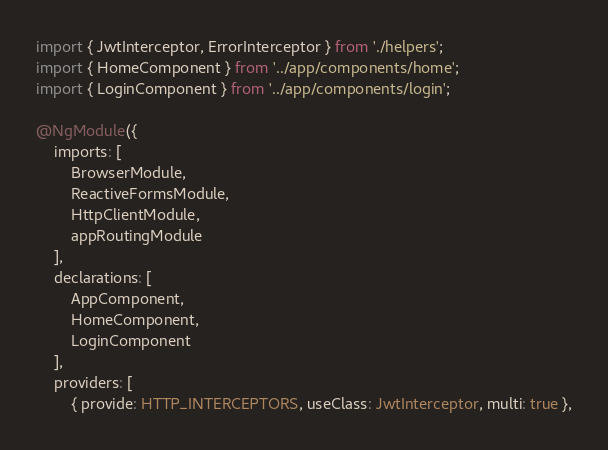Convert code to text. <code><loc_0><loc_0><loc_500><loc_500><_TypeScript_>import { JwtInterceptor, ErrorInterceptor } from './helpers';
import { HomeComponent } from '../app/components/home';
import { LoginComponent } from '../app/components/login';

@NgModule({
    imports: [
        BrowserModule,
        ReactiveFormsModule,
        HttpClientModule,
        appRoutingModule
    ],
    declarations: [
        AppComponent,
        HomeComponent,
        LoginComponent
    ],
    providers: [
        { provide: HTTP_INTERCEPTORS, useClass: JwtInterceptor, multi: true },</code> 